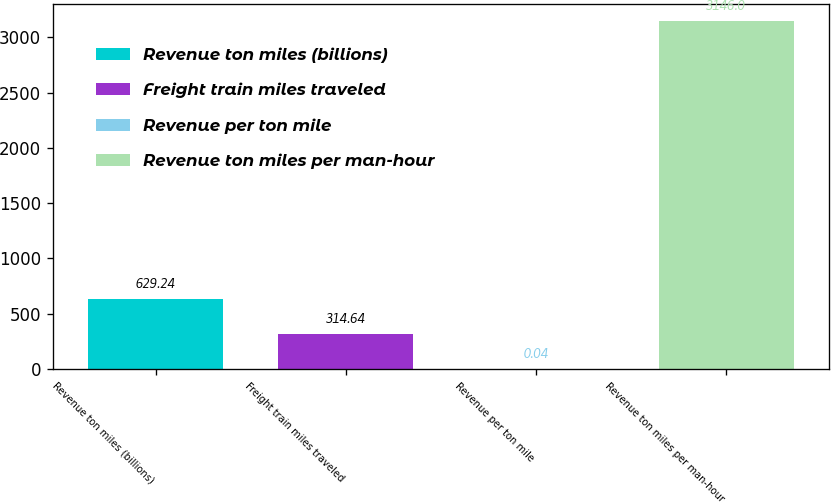<chart> <loc_0><loc_0><loc_500><loc_500><bar_chart><fcel>Revenue ton miles (billions)<fcel>Freight train miles traveled<fcel>Revenue per ton mile<fcel>Revenue ton miles per man-hour<nl><fcel>629.24<fcel>314.64<fcel>0.04<fcel>3146<nl></chart> 